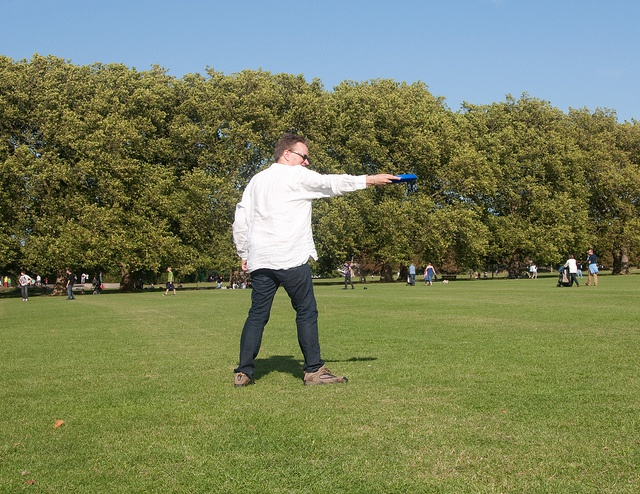Describe the objects in this image and their specific colors. I can see people in lightblue, white, black, and olive tones, people in lightblue, black, gray, darkgreen, and olive tones, people in lightblue, olive, black, and gray tones, people in lightblue, white, black, and gray tones, and people in lightblue, black, gray, lightgray, and darkgray tones in this image. 